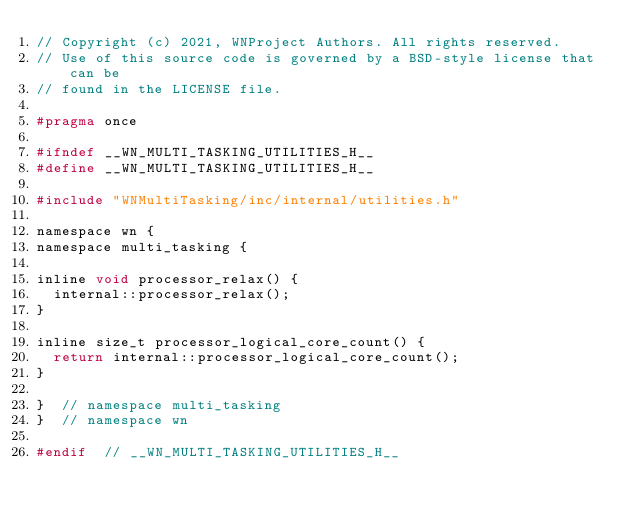Convert code to text. <code><loc_0><loc_0><loc_500><loc_500><_C_>// Copyright (c) 2021, WNProject Authors. All rights reserved.
// Use of this source code is governed by a BSD-style license that can be
// found in the LICENSE file.

#pragma once

#ifndef __WN_MULTI_TASKING_UTILITIES_H__
#define __WN_MULTI_TASKING_UTILITIES_H__

#include "WNMultiTasking/inc/internal/utilities.h"

namespace wn {
namespace multi_tasking {

inline void processor_relax() {
  internal::processor_relax();
}

inline size_t processor_logical_core_count() {
  return internal::processor_logical_core_count();
}

}  // namespace multi_tasking
}  // namespace wn

#endif  // __WN_MULTI_TASKING_UTILITIES_H__
</code> 